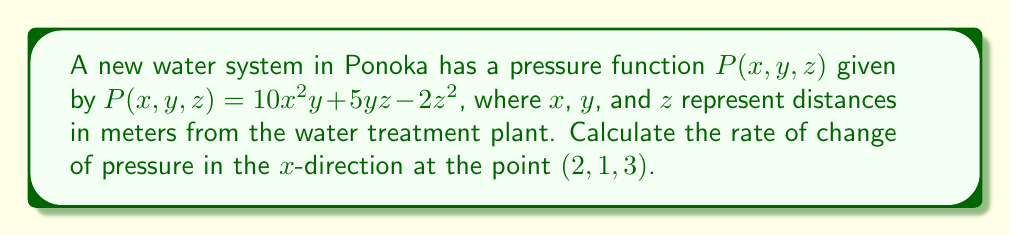Provide a solution to this math problem. To find the rate of change of pressure in the $x$-direction, we need to compute the partial derivative of $P$ with respect to $x$ and evaluate it at the given point.

Step 1: Calculate $\frac{\partial P}{\partial x}$
$$\frac{\partial P}{\partial x} = \frac{\partial}{\partial x}(10x^2y + 5yz - 2z^2) = 20xy$$

Step 2: Evaluate $\frac{\partial P}{\partial x}$ at the point $(2,1,3)$
$$\left.\frac{\partial P}{\partial x}\right|_{(2,1,3)} = 20(2)(1) = 40$$

The units for this rate of change are pressure units per meter, which could be pascals per meter (Pa/m) or pounds per square inch per meter (psi/m), depending on the system of measurement used in Ponoka.
Answer: $40$ pressure units per meter 